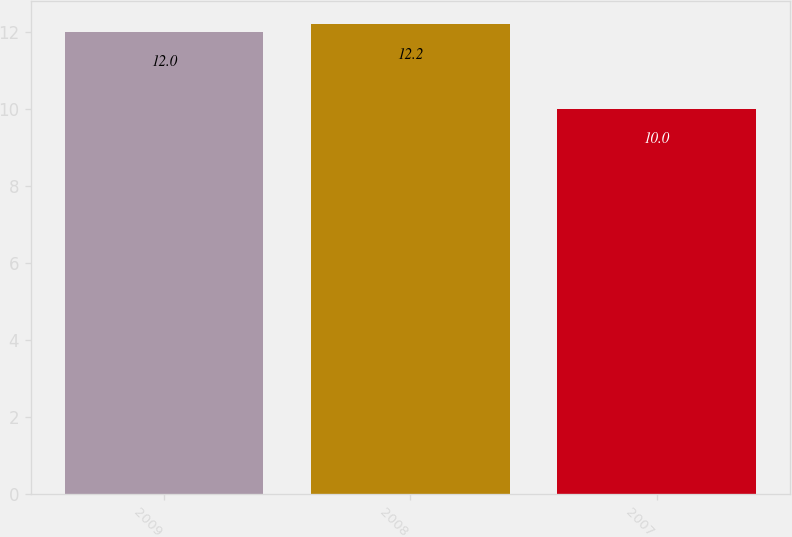Convert chart. <chart><loc_0><loc_0><loc_500><loc_500><bar_chart><fcel>2009<fcel>2008<fcel>2007<nl><fcel>12<fcel>12.2<fcel>10<nl></chart> 